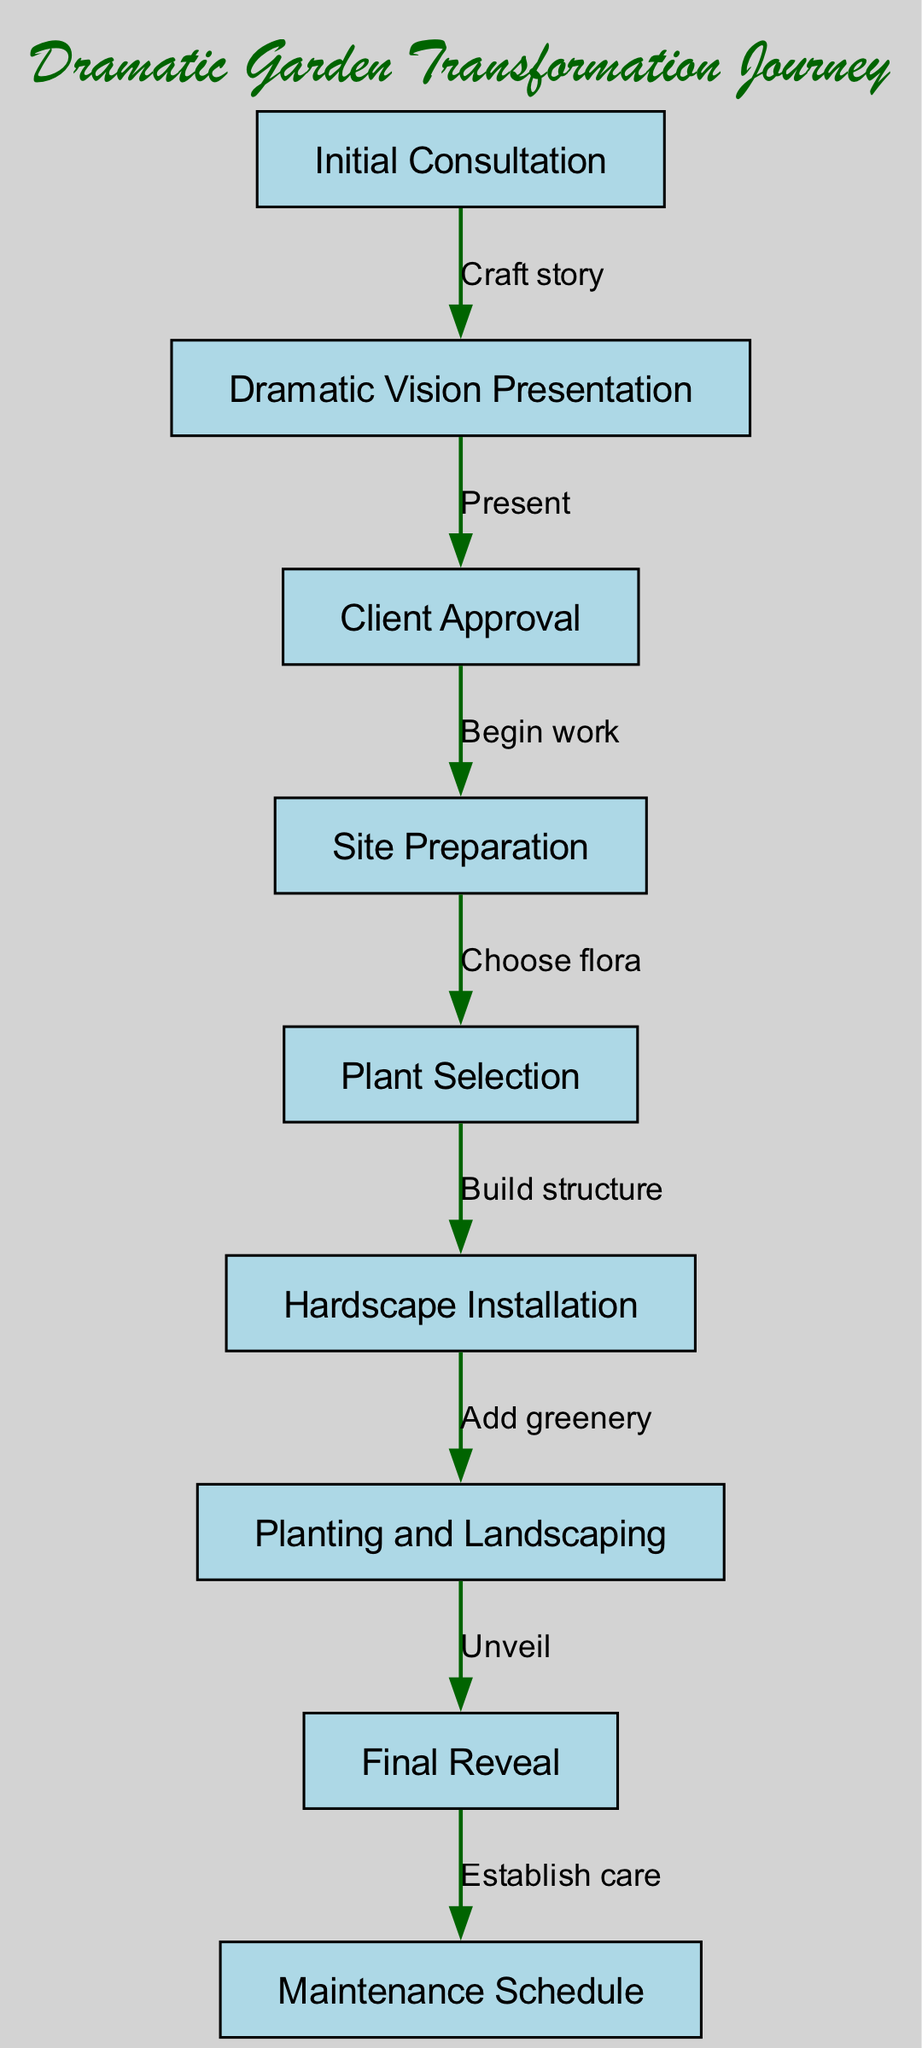What is the first step in the workflow? The first step in the workflow is labeled "Initial Consultation," which indicates that this is where the garden transformation process begins.
Answer: Initial Consultation How many nodes are present in the diagram? The diagram includes a total of nine nodes, each representing a specific step in the garden transformation project workflow.
Answer: 9 What is the label of the node that follows "Plant Selection"? The node following "Plant Selection" is labeled "Hardscape Installation," indicating what comes after choosing the plants.
Answer: Hardscape Installation What action connects "Final Reveal" and "Maintenance Schedule"? The action that connects "Final Reveal" and "Maintenance Schedule" is labeled "Establish care," indicating the focus on ongoing maintenance after unveiling the garden.
Answer: Establish care What is the relationship between "Dramatic Vision Presentation" and "Client Approval"? The relationship between these two nodes is labeled "Present," indicating that the presentation is aimed at gaining the client's approval for the proposed vision.
Answer: Present How does one transition from "Site Preparation" to "Plant Selection"? The transition from "Site Preparation" to "Plant Selection" follows the action labeled "Choose flora," which outlines the step of selecting the appropriate plants for the site after the preparation is completed.
Answer: Choose flora Which node directly follows "Planting and Landscaping"? Directly following "Planting and Landscaping" is the node labeled "Final Reveal,” marking the culmination of the planting process in the project workflow.
Answer: Final Reveal What is the final step in the garden transformation project? The final step is labeled "Maintenance Schedule," which suggests that maintaining the garden is the last step in ensuring its longevity and beauty after the transformation.
Answer: Maintenance Schedule What is the common theme among the actions labeled on the edges? The common theme among the actions labeled on the edges is that they depict sequential steps in the workflow, guiding from initial consultation to care and maintenance of the garden.
Answer: Sequential steps 